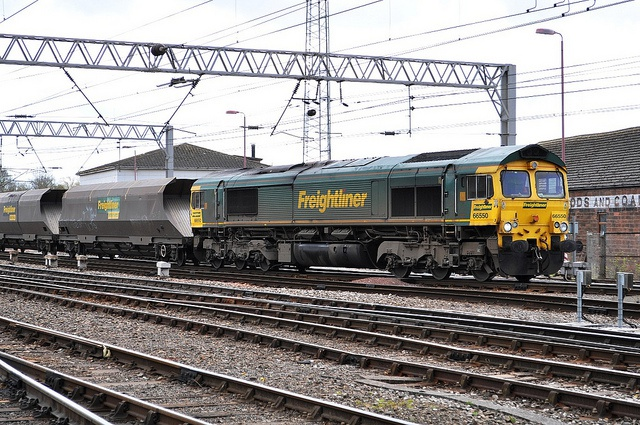Describe the objects in this image and their specific colors. I can see a train in white, black, gray, darkgray, and orange tones in this image. 